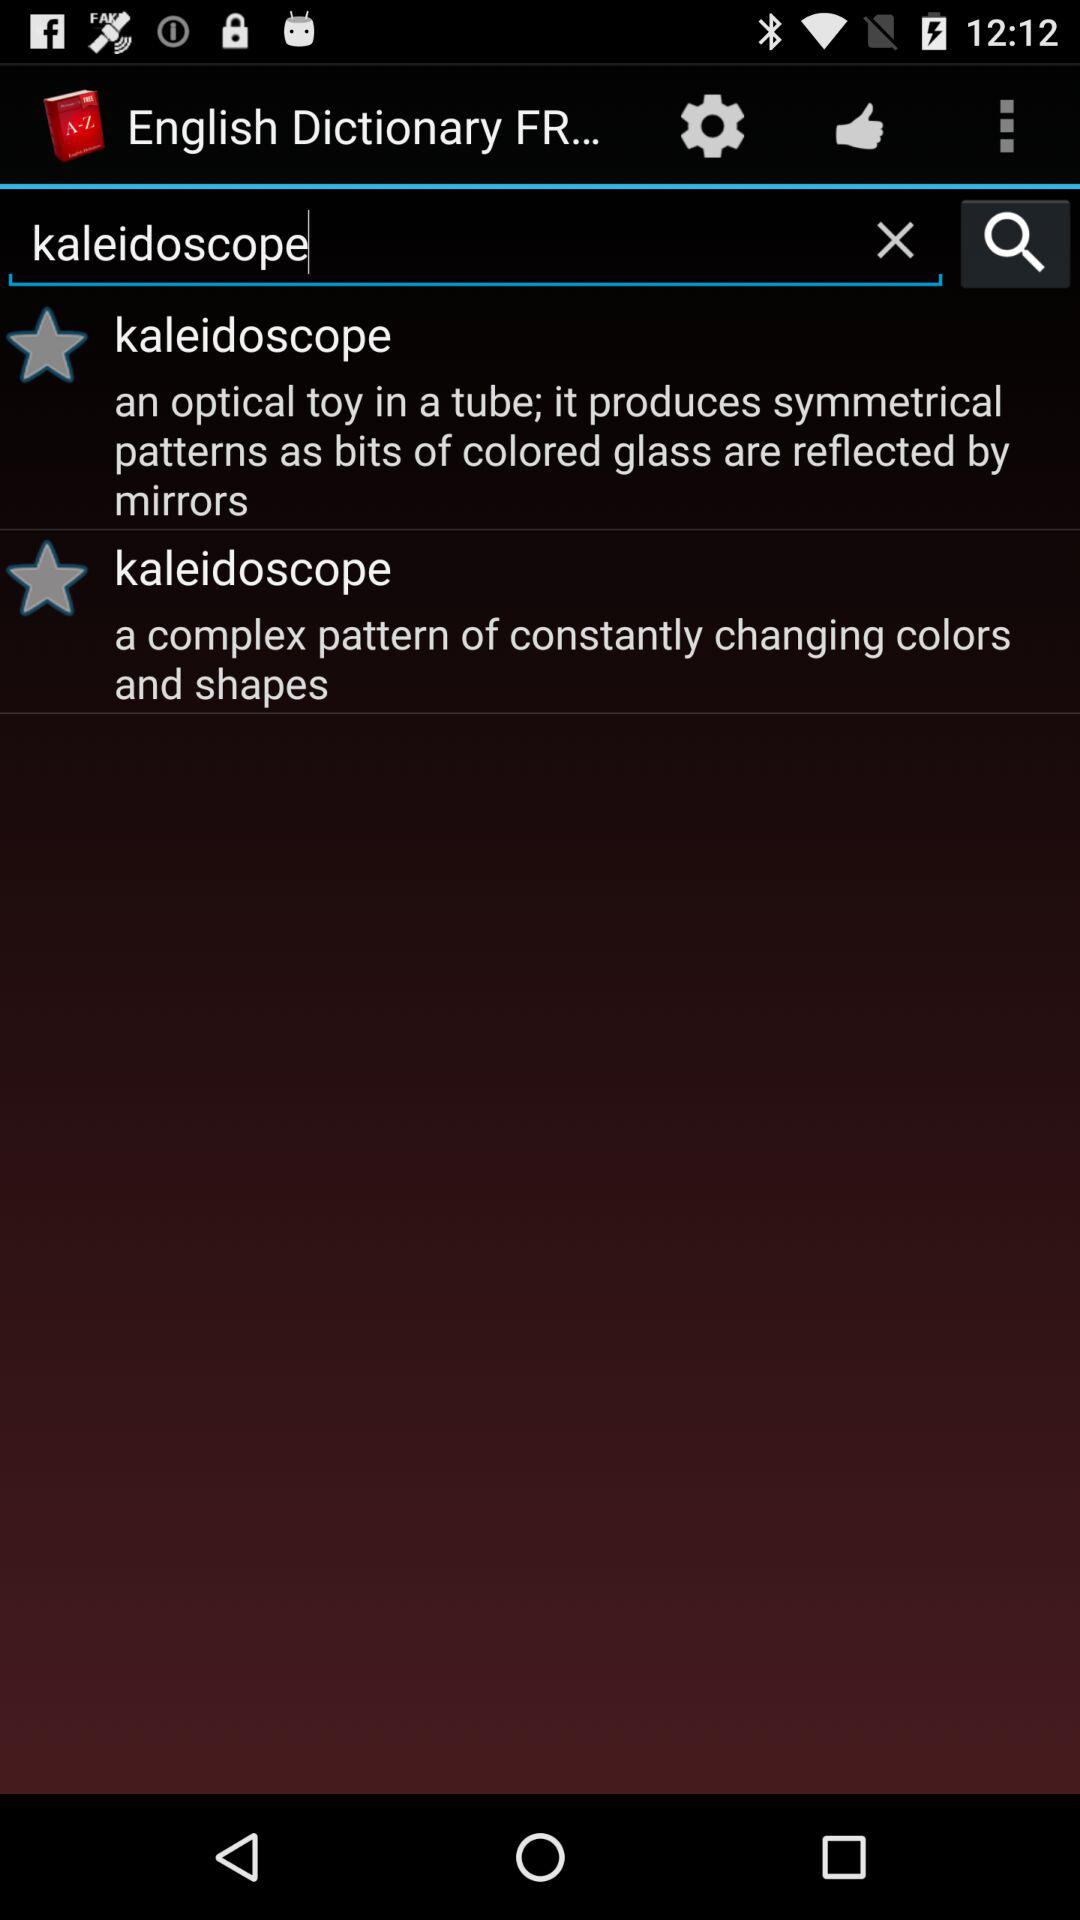What is a kaleidoscope? The kaleidoscope is "an optical toy in a tube; it produces symmetrical patterns as bits of colored glass are reflected by mirrors" and "a complex pattern of constantly changing colors and shapes". 